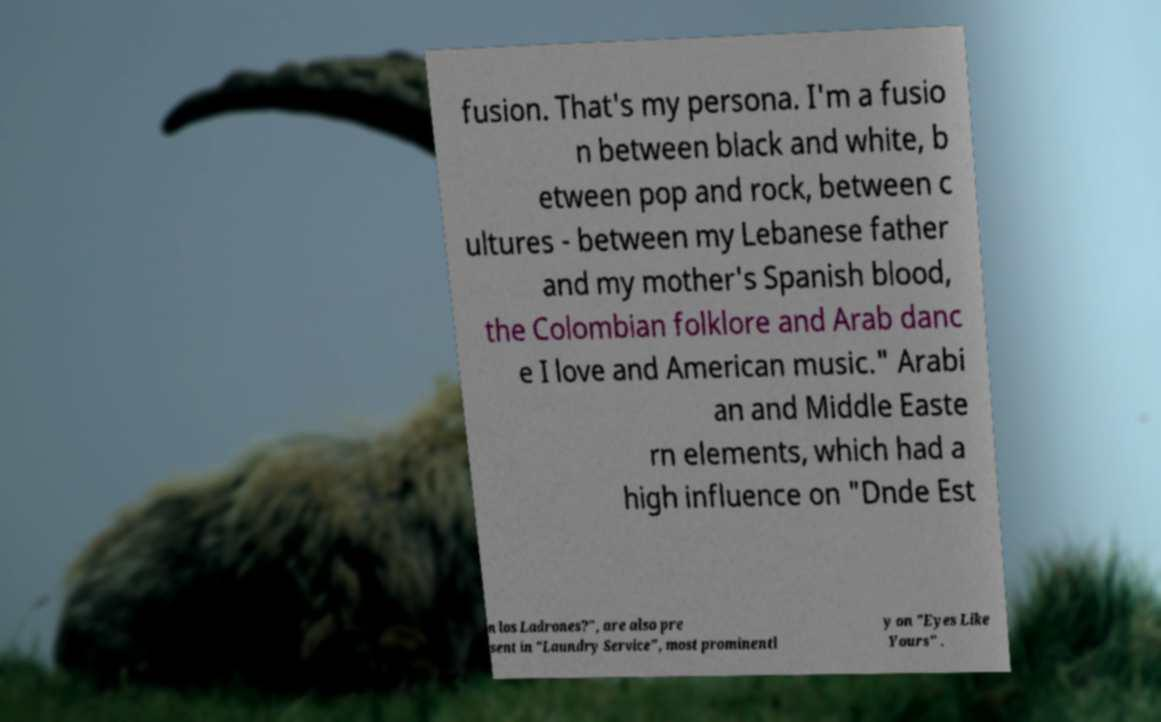There's text embedded in this image that I need extracted. Can you transcribe it verbatim? fusion. That's my persona. I'm a fusio n between black and white, b etween pop and rock, between c ultures - between my Lebanese father and my mother's Spanish blood, the Colombian folklore and Arab danc e I love and American music." Arabi an and Middle Easte rn elements, which had a high influence on "Dnde Est n los Ladrones?", are also pre sent in "Laundry Service", most prominentl y on "Eyes Like Yours" . 